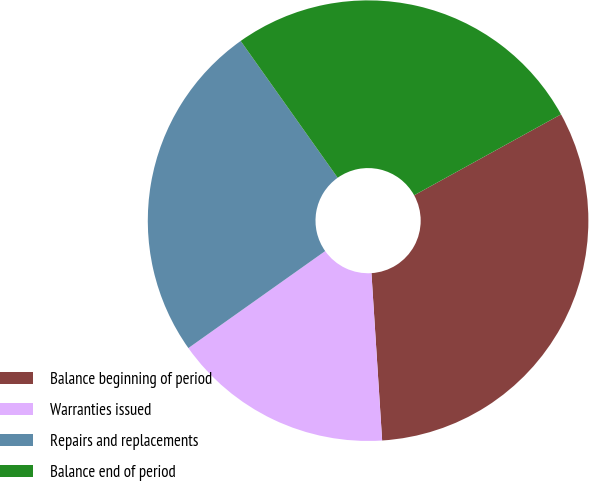<chart> <loc_0><loc_0><loc_500><loc_500><pie_chart><fcel>Balance beginning of period<fcel>Warranties issued<fcel>Repairs and replacements<fcel>Balance end of period<nl><fcel>32.0%<fcel>16.2%<fcel>25.0%<fcel>26.8%<nl></chart> 